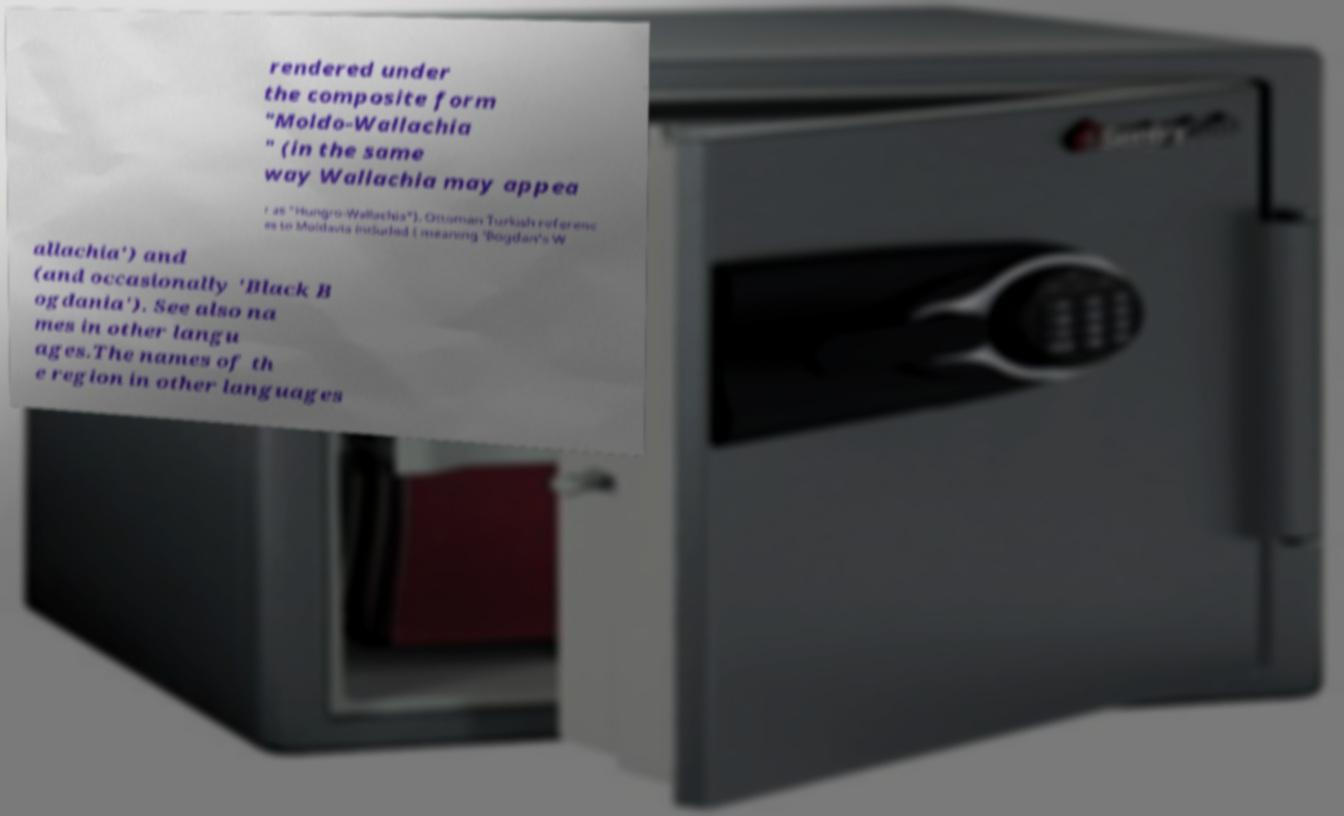Could you assist in decoding the text presented in this image and type it out clearly? rendered under the composite form "Moldo-Wallachia " (in the same way Wallachia may appea r as "Hungro-Wallachia"). Ottoman Turkish referenc es to Moldavia included ( meaning 'Bogdan's W allachia') and (and occasionally 'Black B ogdania'). See also na mes in other langu ages.The names of th e region in other languages 